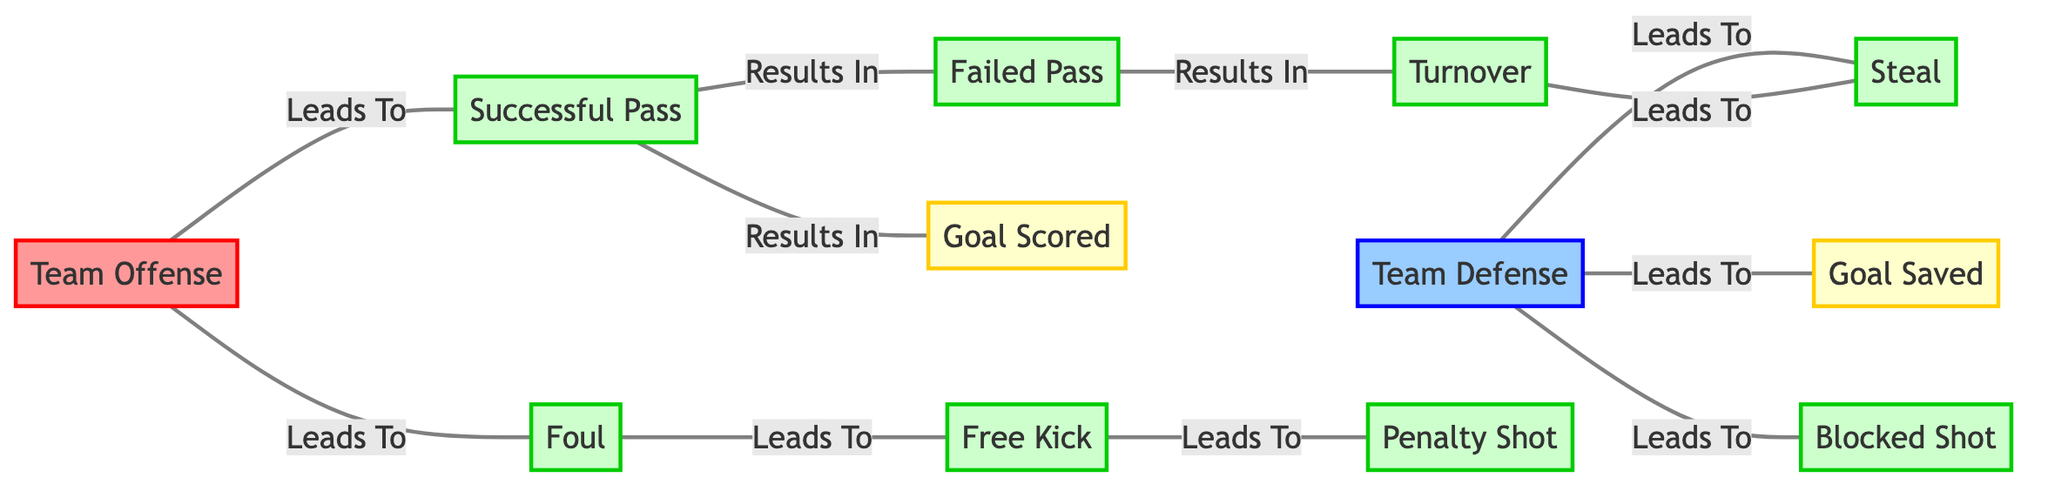What is the total number of nodes in the diagram? The diagram contains a list of nodes, which can be counted. There are 12 distinct entries in the list of nodes provided.
Answer: 12 Which action results from a successful pass? The diagram indicates that a successful pass can lead to two results: a goal scored or a failed pass. The connection labeled "Results In" from the successful pass node shows these two outcomes.
Answer: Goal Scored and Failed Pass What leads to a turnover? A turnover is a result of a failed pass, according to the edges connected to that node. The diagram shows that a failed pass directly results in a turnover.
Answer: Failed Pass How many outcomes can result from team defense? The team defense has three direct outcomes listed: a goal saved, a steal, and a blocked shot. Counting here shows these three results directly lead from the team defense node.
Answer: 3 What leads to a penalty shot? A penalty shot is reached through a series of actions where a foul leads to a free kick, which then leads to a penalty shot. Therefore, we can trace it back through these connections.
Answer: Foul If a failed pass occurs, what action can occur next? Based on the edges from the failed pass, the next action indicated in the diagram is a turnover, as represented by the connection labeled "Results In."
Answer: Turnover How many unique connections are depicted between nodes? To find the number of unique connections, we can count each edge provided in the edge list, which totals 11 connections in this diagram.
Answer: 11 Which node is directly connected to "Team Offense"? The node labeled "Team Offense" has connections leading to two specific actions: a successful pass and a foul. This can be seen from the edges linking directly from this node.
Answer: Successful Pass and Foul What type of node comes after a goal saved? The diagram shows that after a goal saved, no actions follow directly; it is terminal in this flow. So, this node does not lead to any further actions.
Answer: None 